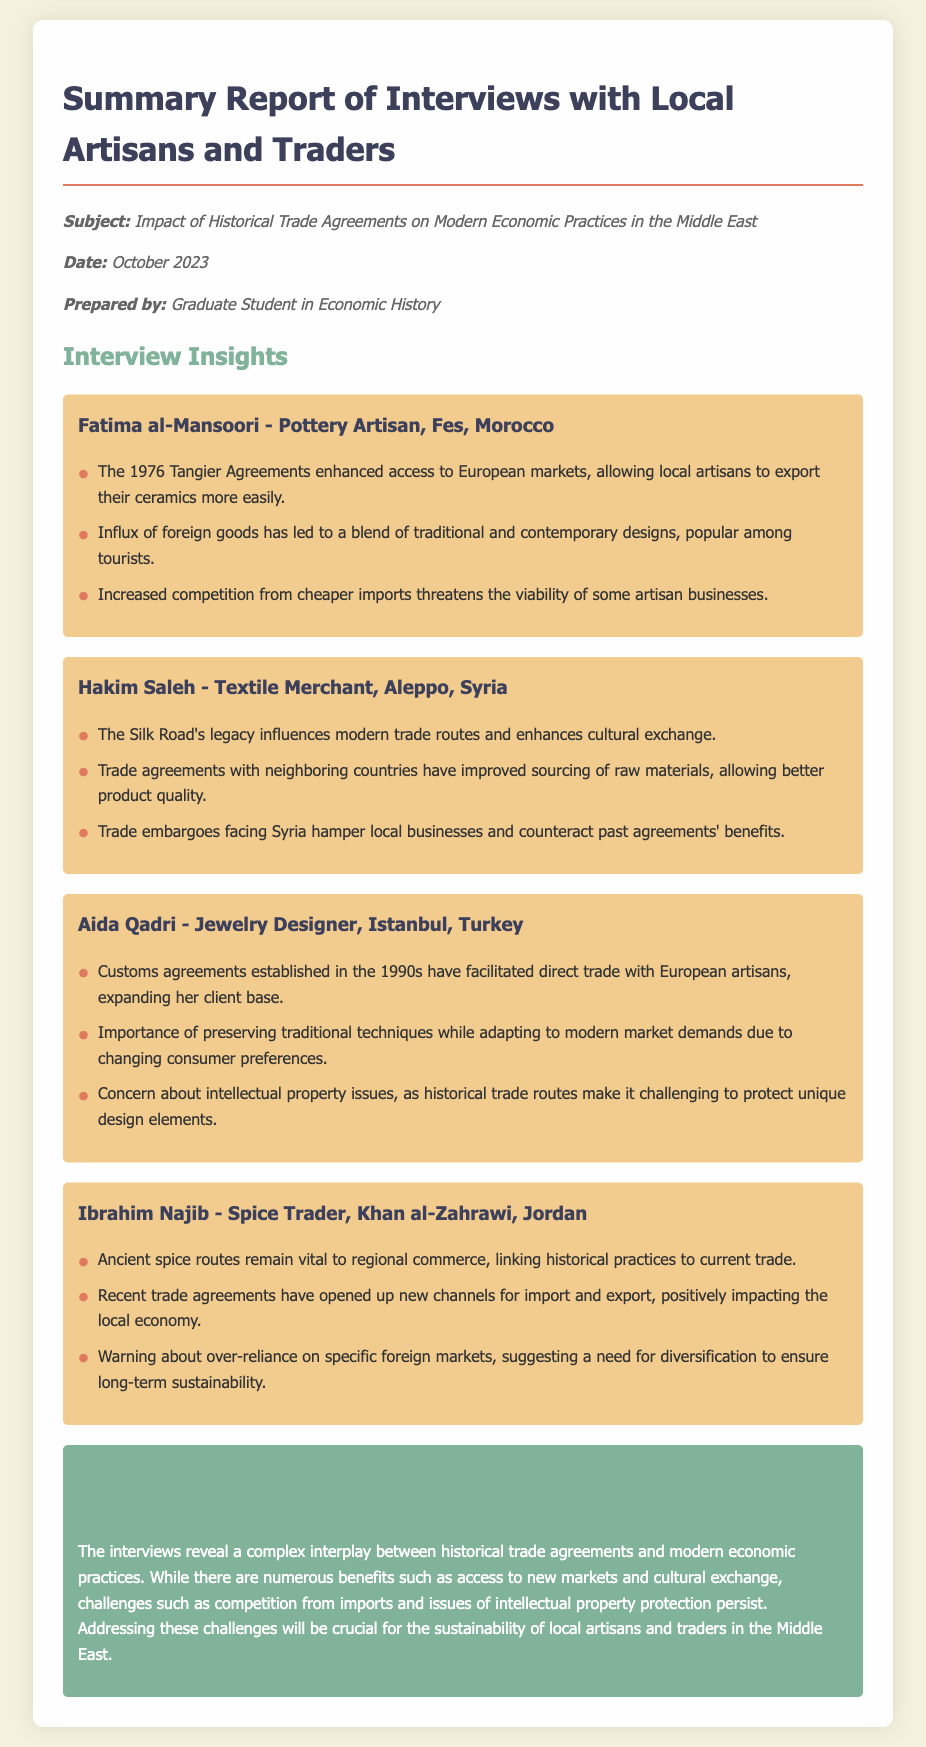What is the subject of the report? The report addresses the impact of historical trade agreements on modern economic practices in the Middle East, as stated in the memo.
Answer: Impact of Historical Trade Agreements on Modern Economic Practices in the Middle East Who is the pottery artisan interviewed? Fatima al-Mansoori is identified as the pottery artisan from Fes, Morocco, in the document.
Answer: Fatima al-Mansoori What year did the Tangier Agreements take place? The memo specifies that the Tangier Agreements were established in 1976.
Answer: 1976 What trade route legacy influences modern trade routes, according to Hakim Saleh? Hakim Saleh mentions the Silk Road's legacy as a critical influence.
Answer: Silk Road What challenges does Aida Qadri express concern about? Aida Qadri is concerned about intellectual property issues facing her unique designs due to historical trade routes.
Answer: Intellectual property issues How have recent trade agreements affected Ibrahim Najib's business? According to Ibrahim Najib, new trade agreements have opened up new channels for import and export, positively impacting his local economy.
Answer: Positively impacting the local economy What is an insight shared by Fatima al-Mansoori regarding foreign goods? Fatima mentions that the influx of foreign goods has led to a blend of traditional and contemporary designs.
Answer: Blend of traditional and contemporary designs What is a recommendation made by Ibrahim Najib regarding foreign markets? Ibrahim Najib suggests a need for diversification to ensure long-term sustainability against reliance on specific foreign markets.
Answer: Diversification What decade did customs agreements facilitating trade with European artisans occur? Aida Qadri refers to customs agreements established in the 1990s that expanded her client base.
Answer: 1990s 